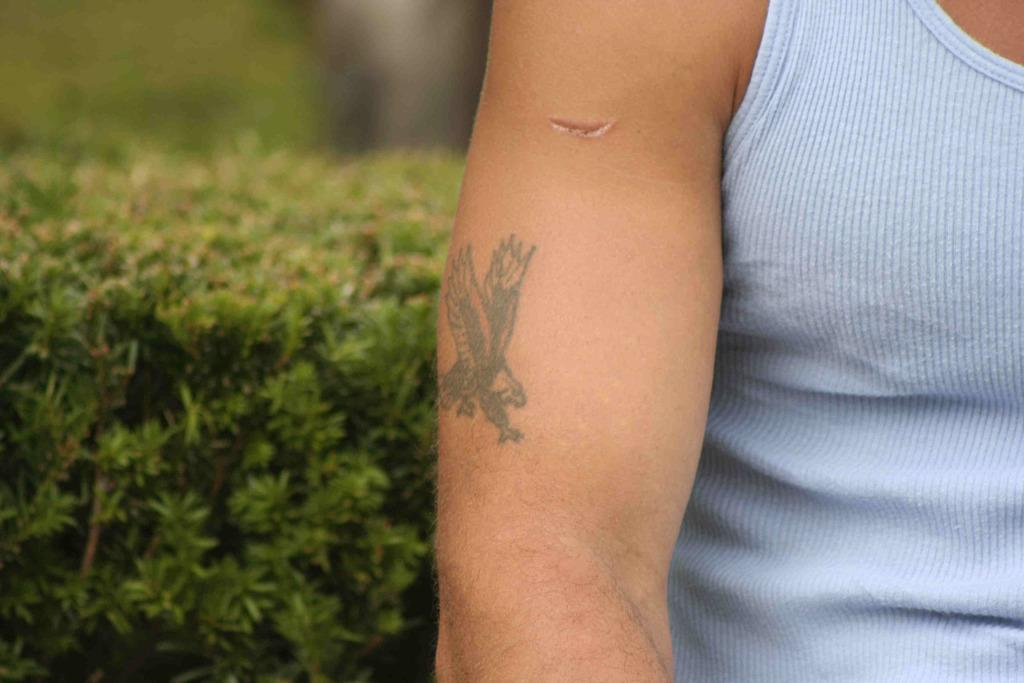What is the main subject of the image? The main subject of the image is a human hand. What can be seen in the background of the image? There are plants in the background of the image. What type of beetle can be seen crawling on the human hand in the image? There is no beetle present on the human hand in the image. How does the frog interact with the plants in the background of the image? There is no frog present in the image, so it cannot interact with the plants. 